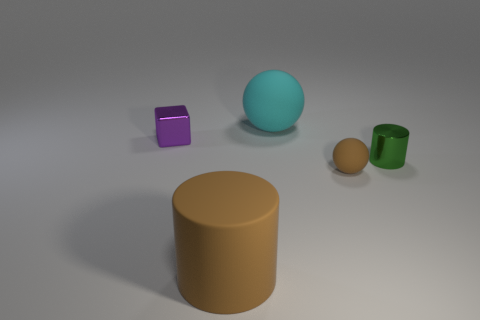Is the number of small purple cubes less than the number of small yellow metal cubes?
Give a very brief answer. No. Are the big cyan ball and the small purple object made of the same material?
Keep it short and to the point. No. How many other objects are the same color as the metal cube?
Provide a short and direct response. 0. Are there more large cyan things than rubber things?
Your response must be concise. No. There is a cyan sphere; is its size the same as the metallic thing that is on the right side of the brown cylinder?
Give a very brief answer. No. The big rubber thing that is behind the tiny rubber ball is what color?
Make the answer very short. Cyan. How many purple things are cylinders or large balls?
Give a very brief answer. 0. What color is the matte cylinder?
Your answer should be very brief. Brown. Are there any other things that have the same material as the tiny brown object?
Your response must be concise. Yes. Is the number of cyan objects in front of the cyan ball less than the number of tiny cubes in front of the small metallic cylinder?
Provide a succinct answer. No. 